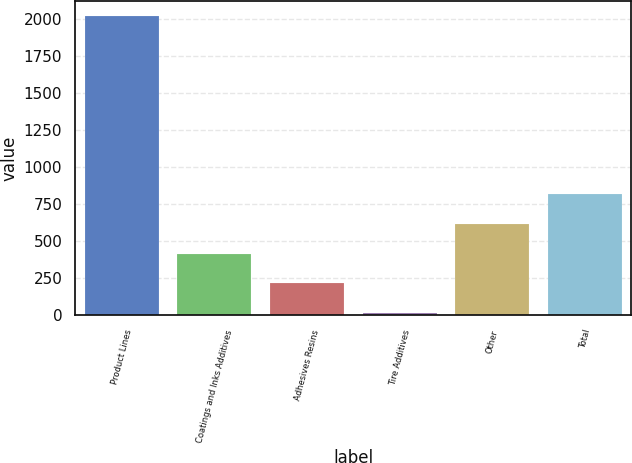<chart> <loc_0><loc_0><loc_500><loc_500><bar_chart><fcel>Product Lines<fcel>Coatings and Inks Additives<fcel>Adhesives Resins<fcel>Tire Additives<fcel>Other<fcel>Total<nl><fcel>2016<fcel>416.8<fcel>216.9<fcel>17<fcel>616.7<fcel>816.6<nl></chart> 